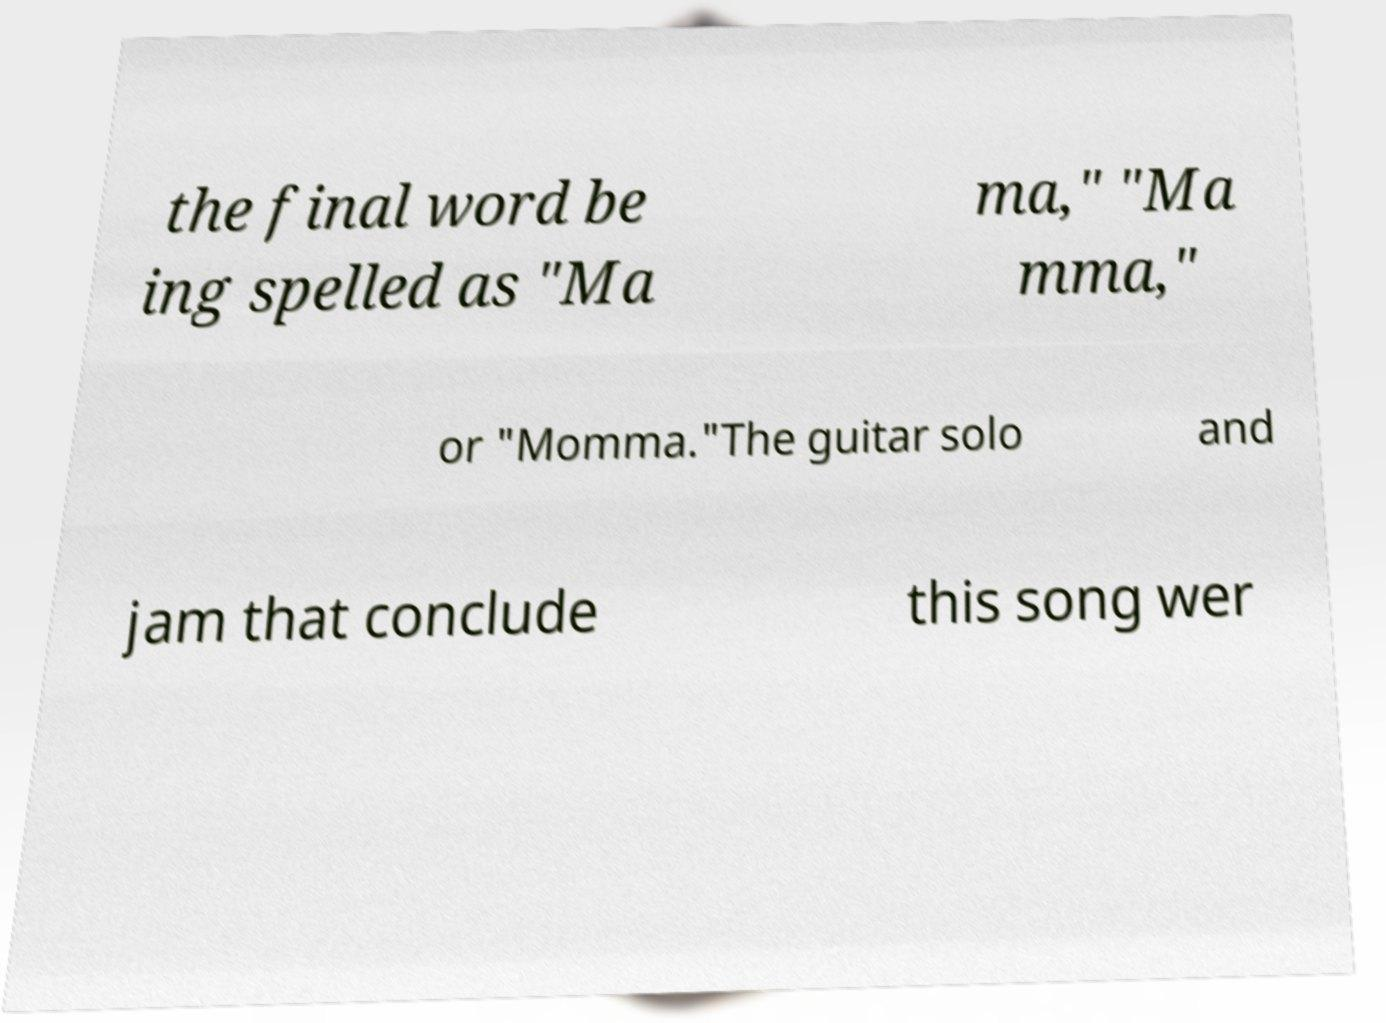Could you extract and type out the text from this image? the final word be ing spelled as "Ma ma," "Ma mma," or "Momma."The guitar solo and jam that conclude this song wer 